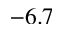Convert formula to latex. <formula><loc_0><loc_0><loc_500><loc_500>- 6 . 7</formula> 